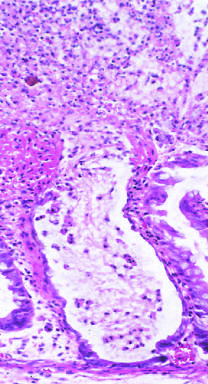what is reminiscent of a volcanic eruption?
Answer the question using a single word or phrase. Typical pattern of neutrophils emanating from crypt 